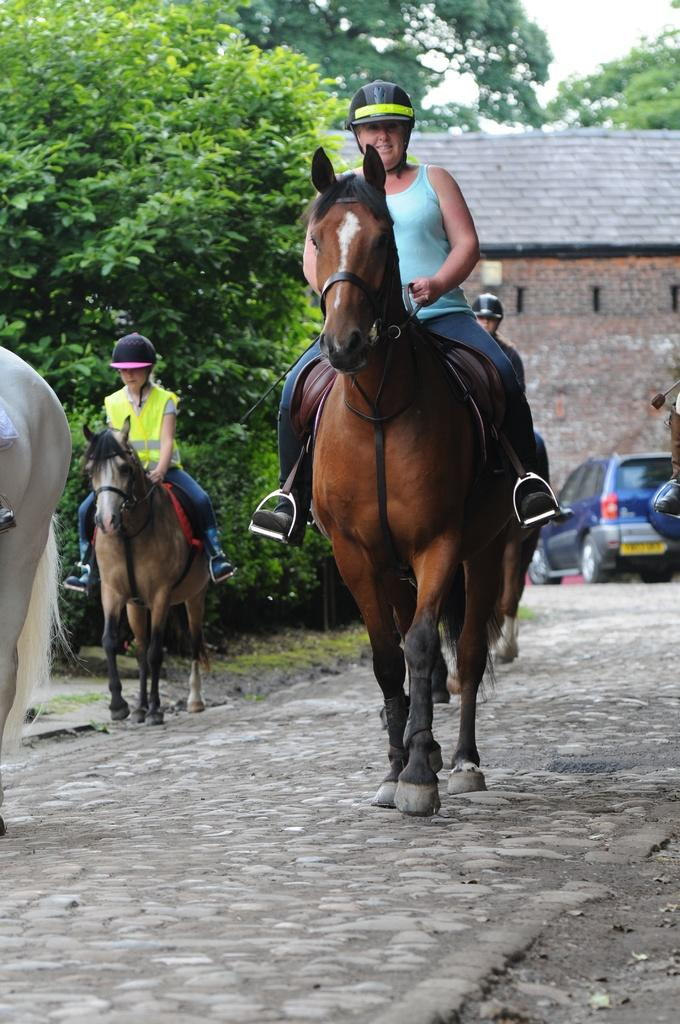What animals are present in the image? There are horses in the image. What are the people doing with the horses? There are people riding the horses. What type of vehicle can be seen in the image? There is a car parked at the right side of the image. What type of vegetation is visible in the image? There are green trees visible in the image. What type of building is present in the image? There is a house in the image. What type of clover can be seen growing near the house in the image? There is no clover visible in the image. Is it raining in the image? The provided facts do not mention any rain in the image. 